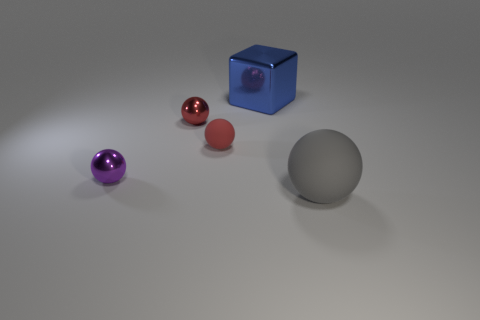There is a thing that is the same color as the tiny matte sphere; what is its shape?
Make the answer very short. Sphere. What number of small objects are blue cubes or balls?
Provide a short and direct response. 3. Is there anything else of the same color as the big shiny cube?
Offer a terse response. No. There is a ball that is on the right side of the small red metal thing and left of the big rubber sphere; what is its size?
Keep it short and to the point. Small. Does the ball on the right side of the large blue shiny thing have the same color as the rubber sphere that is to the left of the blue shiny object?
Keep it short and to the point. No. What number of other objects are the same material as the blue object?
Offer a very short reply. 2. The thing that is in front of the red rubber object and behind the large gray sphere has what shape?
Your response must be concise. Sphere. There is a tiny matte sphere; does it have the same color as the big thing behind the large gray thing?
Your response must be concise. No. Do the matte ball left of the blue object and the big shiny cube have the same size?
Keep it short and to the point. No. What is the material of the purple thing that is the same shape as the tiny red matte object?
Make the answer very short. Metal. 